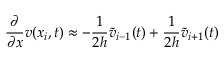Convert formula to latex. <formula><loc_0><loc_0><loc_500><loc_500>\frac { \partial } { \partial x } v ( x _ { i } , t ) \approx - \frac { 1 } { 2 h } \widetilde { v } _ { i - 1 } ( t ) + \frac { 1 } { 2 h } \widetilde { v } _ { i + 1 } ( t )</formula> 